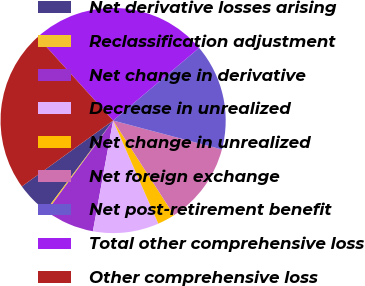Convert chart to OTSL. <chart><loc_0><loc_0><loc_500><loc_500><pie_chart><fcel>Net derivative losses arising<fcel>Reclassification adjustment<fcel>Net change in derivative<fcel>Decrease in unrealized<fcel>Net change in unrealized<fcel>Net foreign exchange<fcel>Net post-retirement benefit<fcel>Total other comprehensive loss<fcel>Other comprehensive loss<nl><fcel>4.83%<fcel>0.2%<fcel>7.14%<fcel>9.45%<fcel>2.52%<fcel>11.77%<fcel>15.3%<fcel>25.55%<fcel>23.24%<nl></chart> 